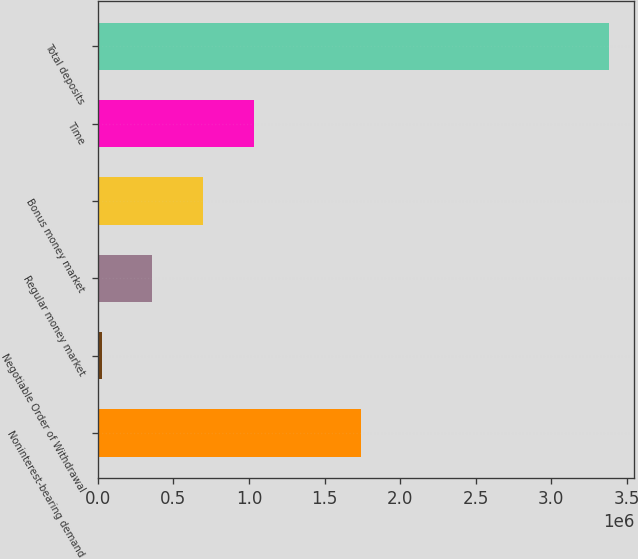Convert chart to OTSL. <chart><loc_0><loc_0><loc_500><loc_500><bar_chart><fcel>Noninterest-bearing demand<fcel>Negotiable Order of Withdrawal<fcel>Regular money market<fcel>Bonus money market<fcel>Time<fcel>Total deposits<nl><fcel>1.73746e+06<fcel>25401<fcel>360939<fcel>696476<fcel>1.03201e+06<fcel>3.38078e+06<nl></chart> 